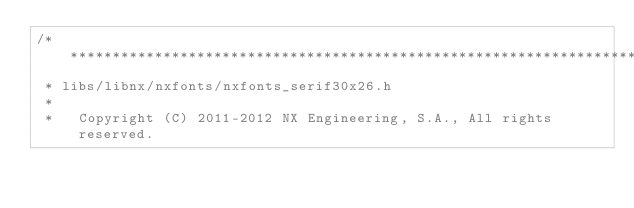<code> <loc_0><loc_0><loc_500><loc_500><_C_>/****************************************************************************
 * libs/libnx/nxfonts/nxfonts_serif30x26.h
 *
 *   Copyright (C) 2011-2012 NX Engineering, S.A., All rights reserved.</code> 